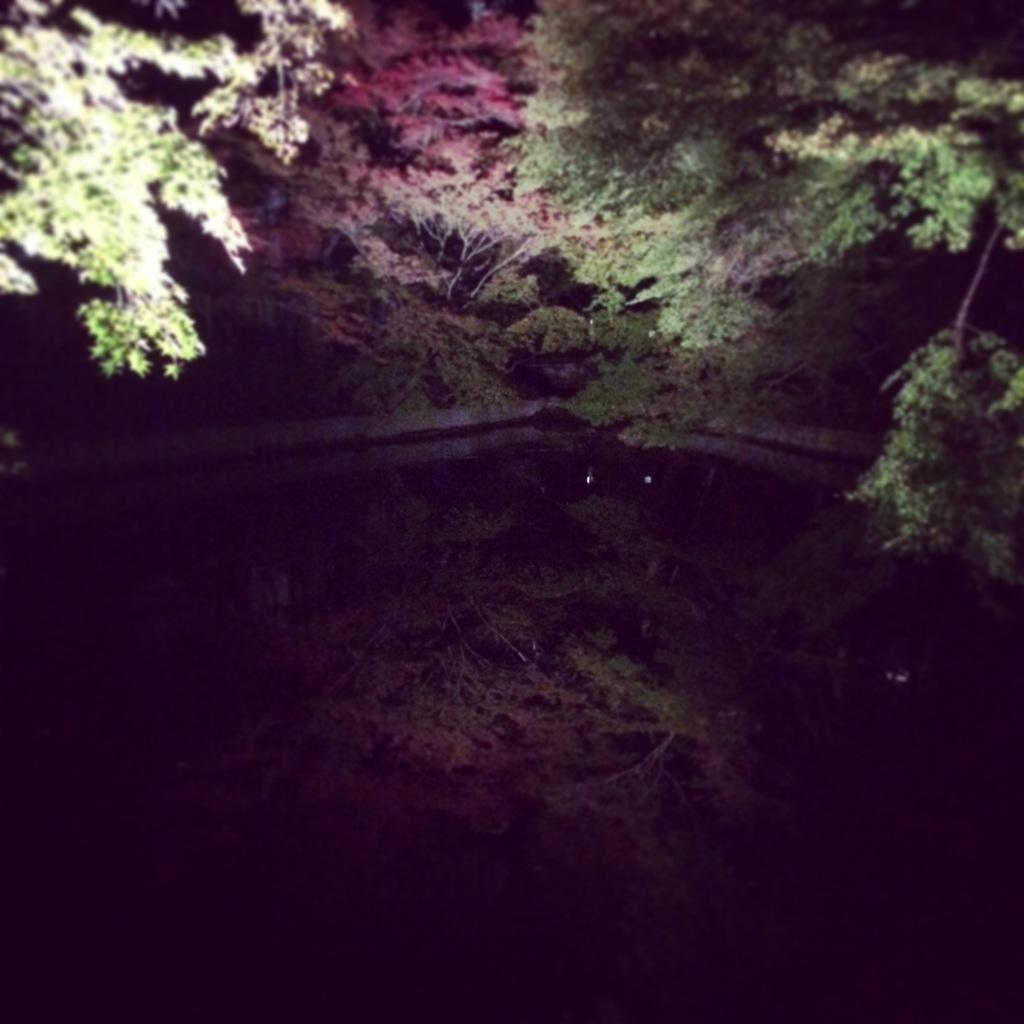Could you give a brief overview of what you see in this image? In this picture we can see trees and in the bottom we can see water. 